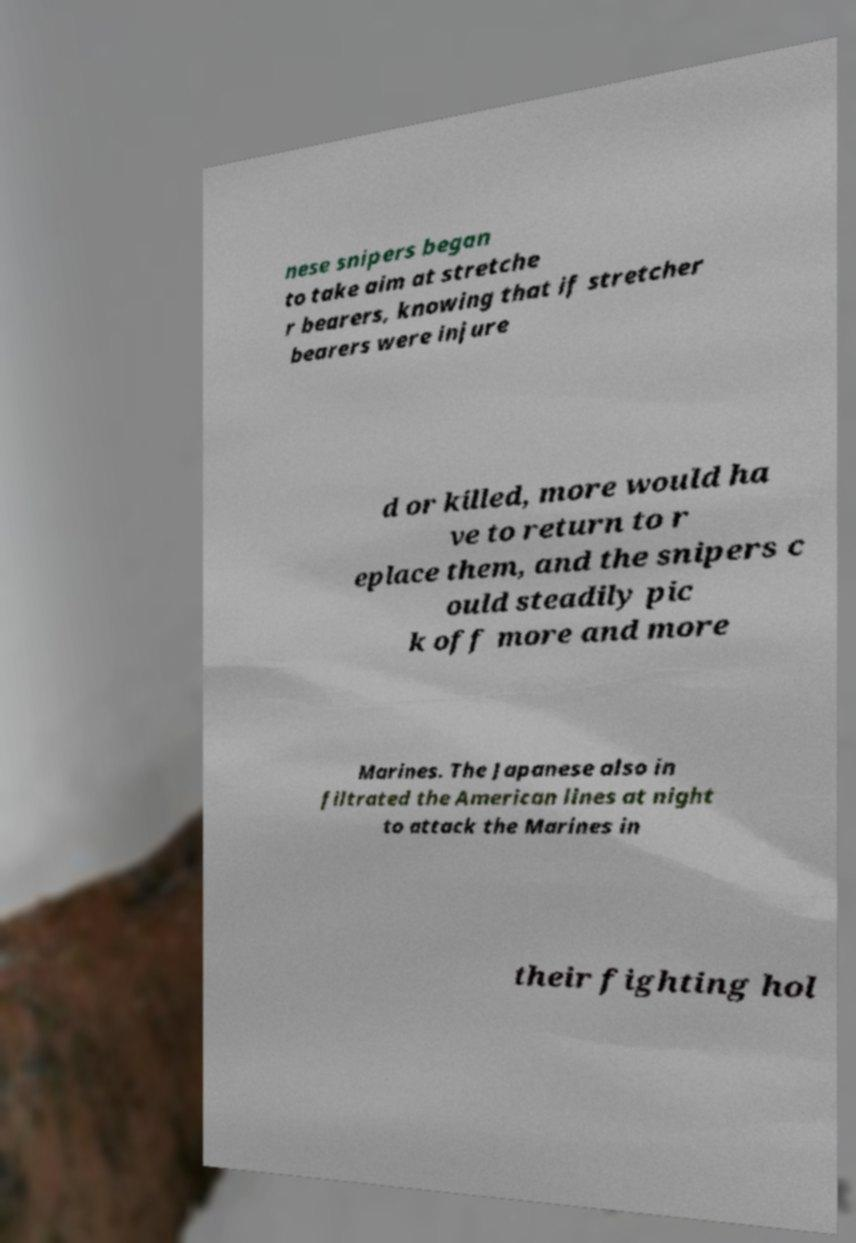Can you accurately transcribe the text from the provided image for me? nese snipers began to take aim at stretche r bearers, knowing that if stretcher bearers were injure d or killed, more would ha ve to return to r eplace them, and the snipers c ould steadily pic k off more and more Marines. The Japanese also in filtrated the American lines at night to attack the Marines in their fighting hol 